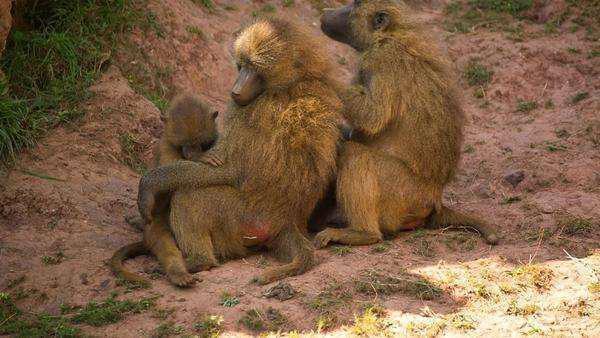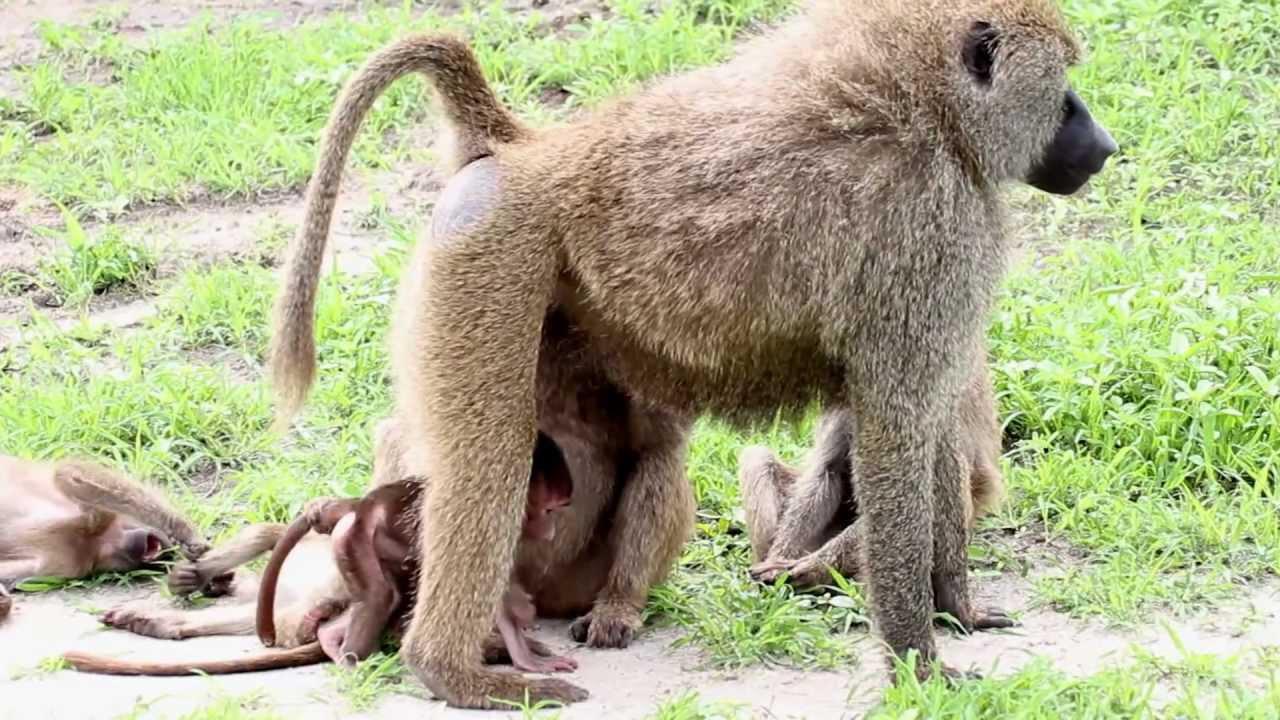The first image is the image on the left, the second image is the image on the right. Given the left and right images, does the statement "There are exactly four monkeys." hold true? Answer yes or no. No. The first image is the image on the left, the second image is the image on the right. Assess this claim about the two images: "An image includes a brown monkey with its arms reaching down below its head and its rear higher than its head.". Correct or not? Answer yes or no. No. 